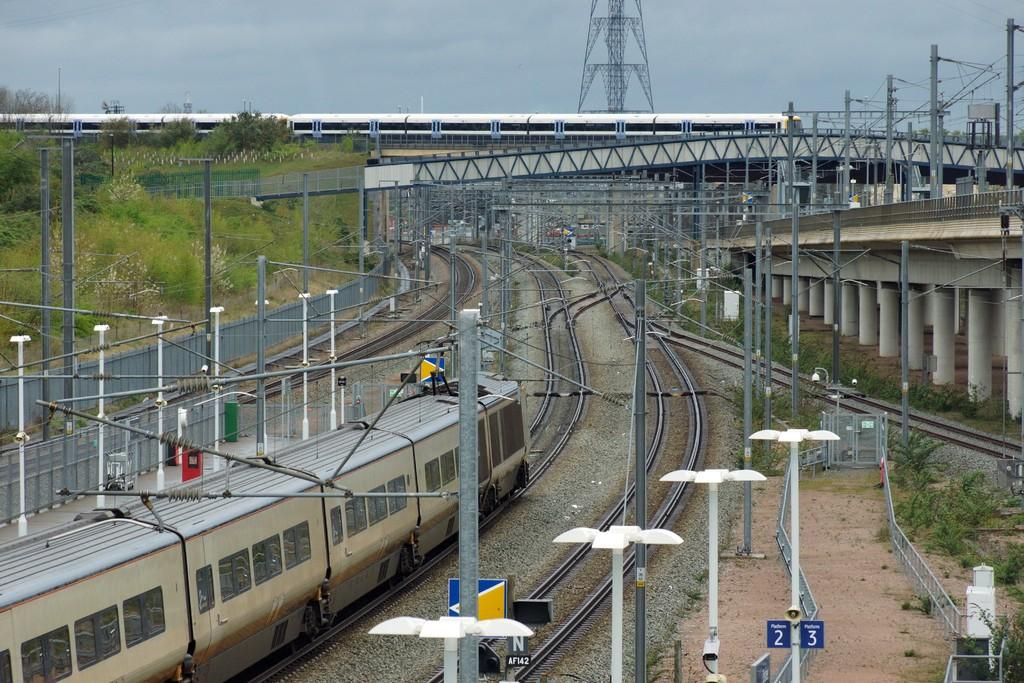<image>
Summarize the visual content of the image. Train tracks in a train yard with platform 2 and platform 3 